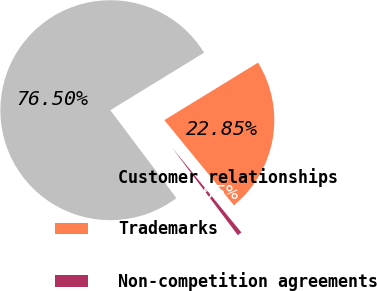<chart> <loc_0><loc_0><loc_500><loc_500><pie_chart><fcel>Customer relationships<fcel>Trademarks<fcel>Non-competition agreements<nl><fcel>76.5%<fcel>22.85%<fcel>0.65%<nl></chart> 